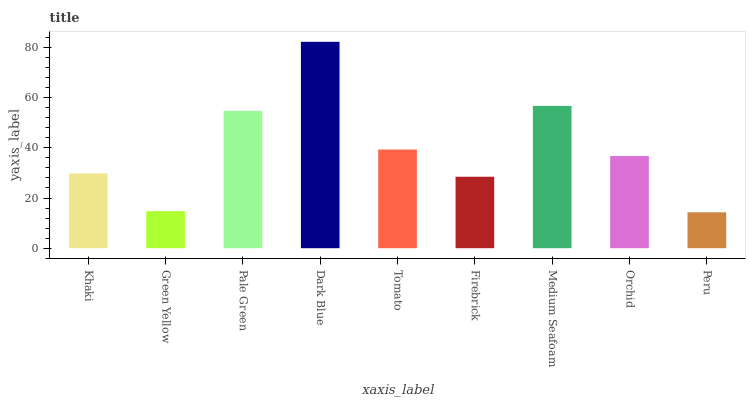Is Peru the minimum?
Answer yes or no. Yes. Is Dark Blue the maximum?
Answer yes or no. Yes. Is Green Yellow the minimum?
Answer yes or no. No. Is Green Yellow the maximum?
Answer yes or no. No. Is Khaki greater than Green Yellow?
Answer yes or no. Yes. Is Green Yellow less than Khaki?
Answer yes or no. Yes. Is Green Yellow greater than Khaki?
Answer yes or no. No. Is Khaki less than Green Yellow?
Answer yes or no. No. Is Orchid the high median?
Answer yes or no. Yes. Is Orchid the low median?
Answer yes or no. Yes. Is Peru the high median?
Answer yes or no. No. Is Firebrick the low median?
Answer yes or no. No. 